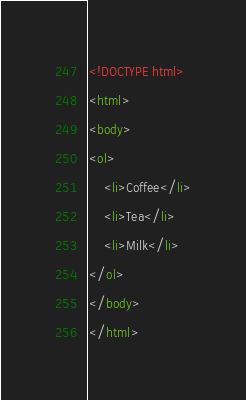Convert code to text. <code><loc_0><loc_0><loc_500><loc_500><_HTML_><!DOCTYPE html>
<html>
<body>
<ol>
    <li>Coffee</li>
    <li>Tea</li>
    <li>Milk</li>
</ol>
</body>
</html>
</code> 